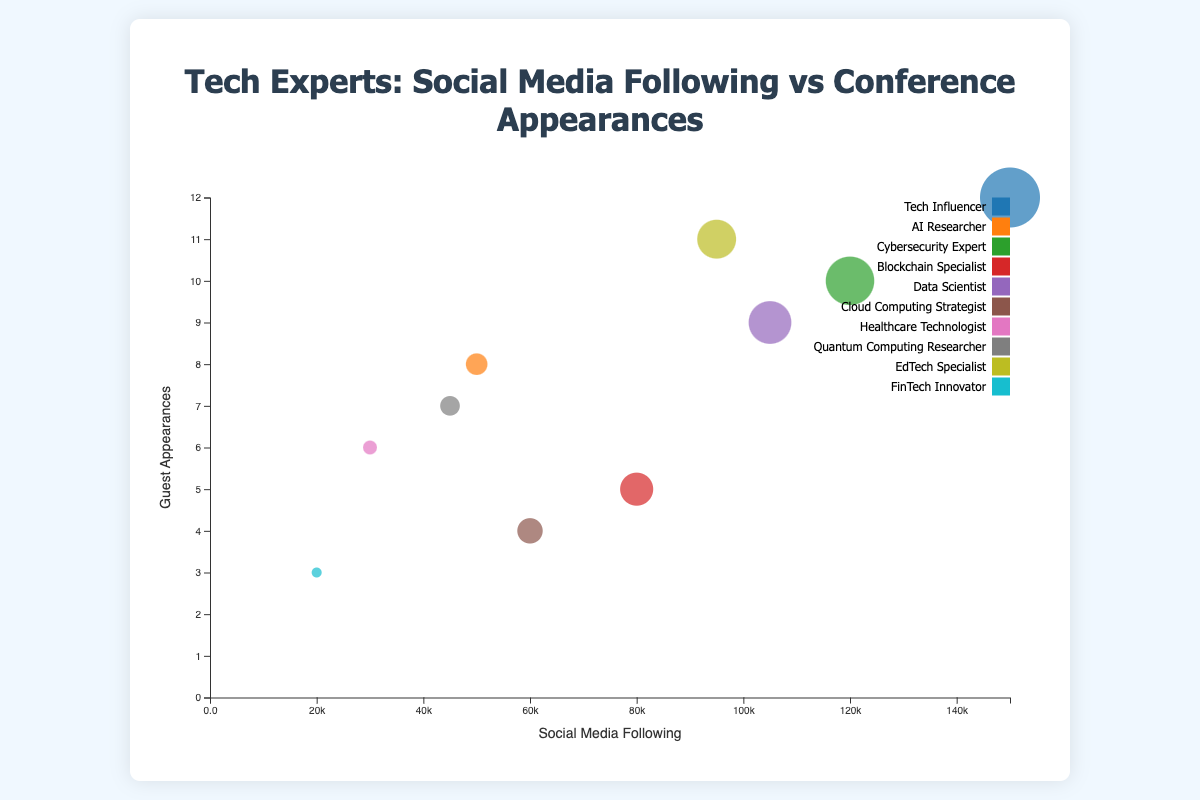What is the title of the chart? The title is displayed prominently at the top of the figure. It's usually larger and more distinct in font compared to other text elements in the chart, making it easy to identify.
Answer: Tech Experts: Social Media Following vs Conference Appearances Which expert has the highest social media following? To determine this, locate the x-axis and identify the bubble farthest to the right. The tooltip or legend will help in recognizing the expert.
Answer: Jane Doe How many guest appearances did the expert with the lowest social media following have? The lowest social media following is represented by the bubble closest to the y-axis (>0). Using the tooltip or legend, we can identify the expert corresponding to this bubble and count the guest appearances.
Answer: 3 (Paul Walker) Which occupation is represented by the most colorful bubble? The bubbles’ colors are linked to occupations; checking the legend will reveal which color represents which occupation. The occupation with the most appearances typically has multiple bubbles with the same color.
Answer: Various occupations (using legend is necessary) What is the average number of guest appearances among the experts? Sum up the guest appearances of all experts and divide by the total number of experts. The total guest appearances are 12 + 8 + 10 + 5 + 9 + 4 + 6 + 7 + 11 + 3 = 75 and there are 10 experts. Average = 75 / 10.
Answer: 7.5 Which expert has a higher number of guest appearances, Emily Davis or Chris Lewis? Check the positions of Emily Davis and Chris Lewis on the y-axis. The bubble higher on the y-axis represents the expert with more guest appearances.
Answer: Emily Davis Is there a general correlation between social media following and guest appearances? Observe the overall trend of the bubbles. If the bubbles tend to go upwards as they move to the right, there's a positive correlation. If the bubbles are scattered randomly, there's no clear correlation.
Answer: Yes, positive correlation Comparing only the experts specializing in AI and Quantum Computing, who has more guest appearances? Locate the bubbles for the AI Researcher (John Smith) and the Quantum Computing Researcher (Chris Lewis). Compare their y-axis positions to determine who has more guest appearances.
Answer: John Smith Which expert falls closest to the middle of the chart both in terms of social media following and guest appearances? Identify the bubble nearest to the average values on both axes. Approximate the middle positions on x and y axes and find the closest bubble.
Answer: Emily Davis Comparing experts with social media followings below 50,000, who has the least number of guest appearances? Identify the bubbles on the left side of the x-axis (below 50,000) and compare their y-axis positions. The bubble lowest on the y-axis indicates the least appearances.
Answer: Paul Walker 